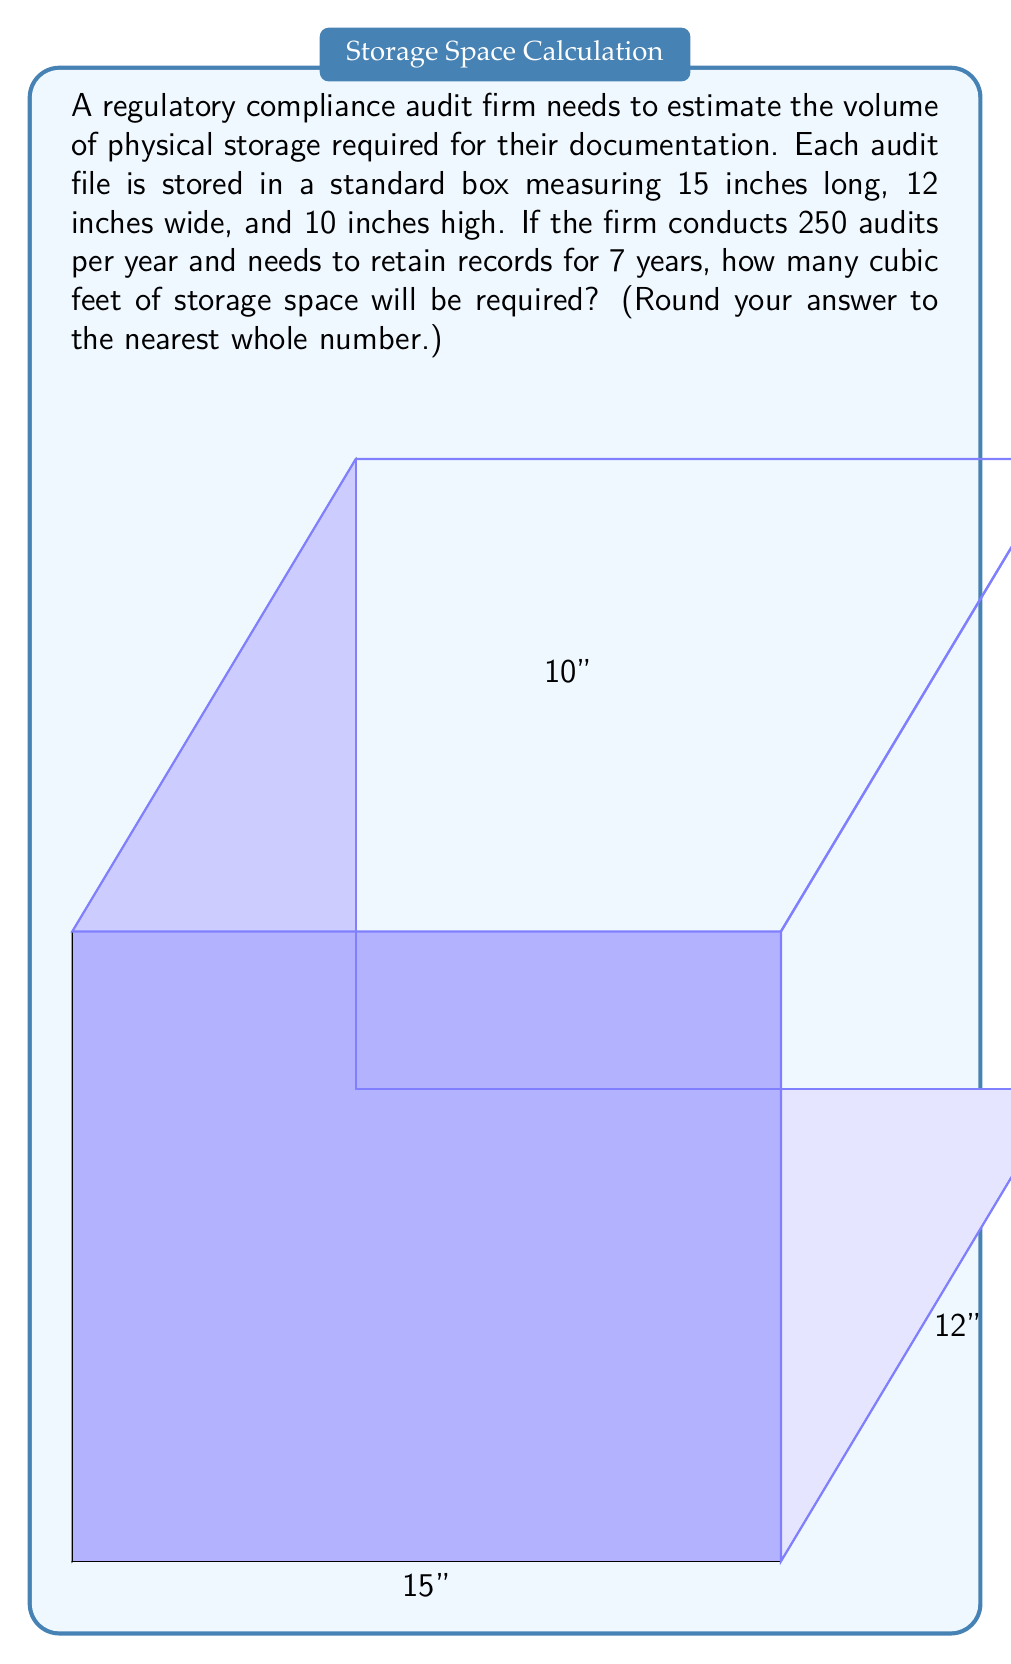Show me your answer to this math problem. Let's approach this step-by-step:

1) First, we need to calculate the volume of a single box:
   $V_{box} = 15 \text{ inches} \times 12 \text{ inches} \times 10 \text{ inches} = 1800 \text{ cubic inches}$

2) Now, we need to determine the total number of boxes:
   - Number of audits per year: 250
   - Number of years to retain records: 7
   Total boxes = $250 \times 7 = 1750$ boxes

3) Calculate the total volume in cubic inches:
   $V_{total} = 1800 \text{ cubic inches} \times 1750 = 3,150,000 \text{ cubic inches}$

4) Convert cubic inches to cubic feet:
   We know that 1 cubic foot = 12 × 12 × 12 = 1,728 cubic inches
   
   $V_{cubic feet} = \frac{3,150,000 \text{ cubic inches}}{1,728 \text{ cubic inches/cubic foot}} \approx 1822.92 \text{ cubic feet}$

5) Rounding to the nearest whole number:
   $1822.92 \approx 1823 \text{ cubic feet}$
Answer: 1823 cubic feet 